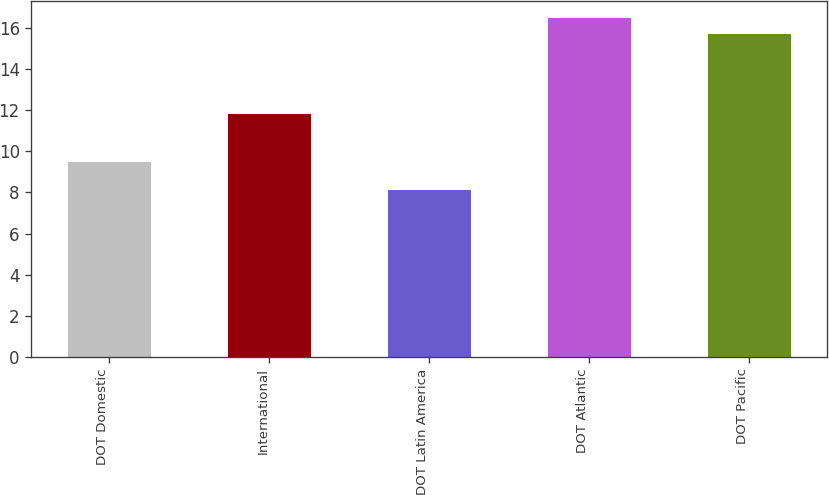<chart> <loc_0><loc_0><loc_500><loc_500><bar_chart><fcel>DOT Domestic<fcel>International<fcel>DOT Latin America<fcel>DOT Atlantic<fcel>DOT Pacific<nl><fcel>9.5<fcel>11.8<fcel>8.1<fcel>16.48<fcel>15.7<nl></chart> 